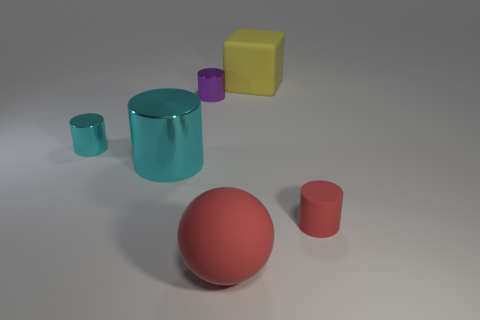Subtract all green cylinders. Subtract all brown balls. How many cylinders are left? 4 Add 2 large red metallic cylinders. How many objects exist? 8 Subtract all cylinders. How many objects are left? 2 Add 5 cyan metal cylinders. How many cyan metal cylinders are left? 7 Add 2 tiny yellow matte cylinders. How many tiny yellow matte cylinders exist? 2 Subtract 0 blue cylinders. How many objects are left? 6 Subtract all rubber cylinders. Subtract all big matte things. How many objects are left? 3 